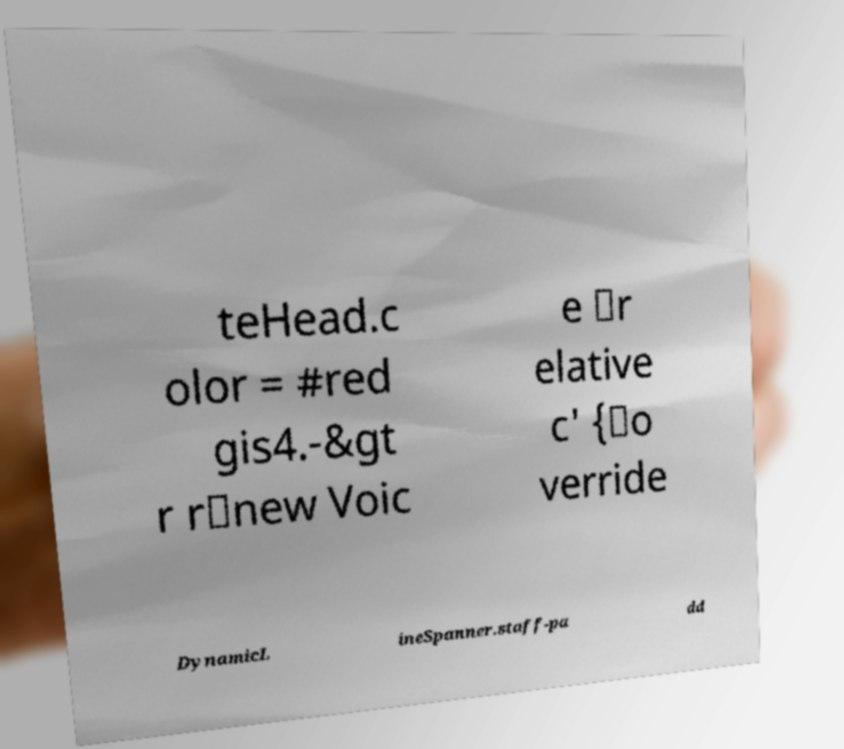Could you extract and type out the text from this image? teHead.c olor = #red gis4.-&gt r r\new Voic e \r elative c' {\o verride DynamicL ineSpanner.staff-pa dd 